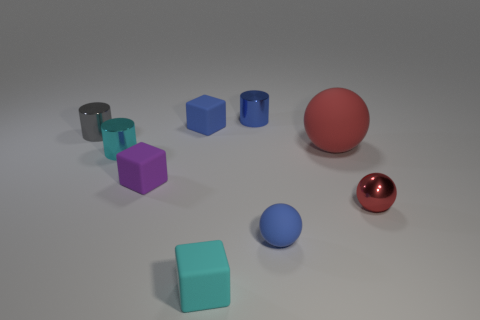There is a ball behind the tiny red sphere; is it the same size as the rubber block that is behind the purple object?
Your response must be concise. No. Are there more blue spheres that are to the left of the small blue cylinder than tiny blue spheres behind the tiny rubber sphere?
Your answer should be compact. No. How many other things are the same color as the tiny rubber ball?
Provide a succinct answer. 2. There is a metallic sphere; is it the same color as the tiny rubber thing to the right of the small blue metallic cylinder?
Your answer should be very brief. No. What number of small metal objects are left of the blue rubber object that is in front of the tiny gray metallic thing?
Your answer should be very brief. 3. Are there any other things that are made of the same material as the big red sphere?
Ensure brevity in your answer.  Yes. There is a red thing that is in front of the tiny cyan thing that is left of the tiny cyan object in front of the purple matte block; what is its material?
Provide a succinct answer. Metal. What material is the small object that is both right of the small blue metallic object and in front of the tiny red object?
Your answer should be compact. Rubber. What number of small cyan matte things have the same shape as the red metal thing?
Your response must be concise. 0. There is a rubber cube behind the small cylinder that is left of the tiny cyan shiny cylinder; what is its size?
Ensure brevity in your answer.  Small. 